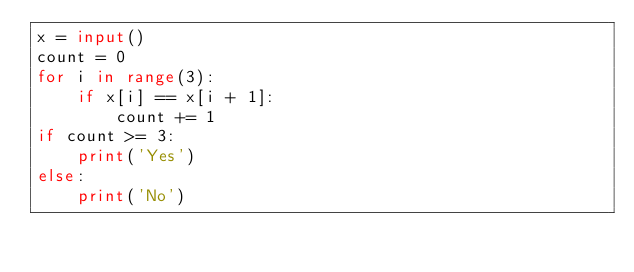Convert code to text. <code><loc_0><loc_0><loc_500><loc_500><_Python_>x = input()
count = 0
for i in range(3):
	if x[i] == x[i + 1]:
		count += 1
if count >= 3:
	print('Yes')
else:
	print('No')</code> 